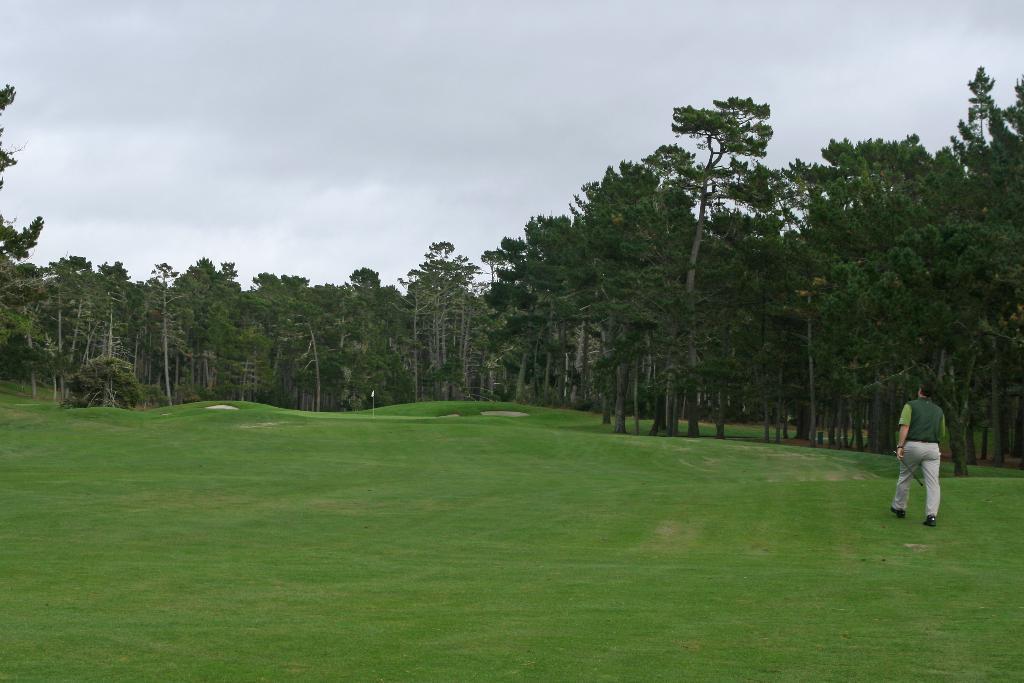Could you give a brief overview of what you see in this image? As we can see in the image there is grass, a person wearing green color jacket and walking on the right side. There are trees and at the top there is sky. 